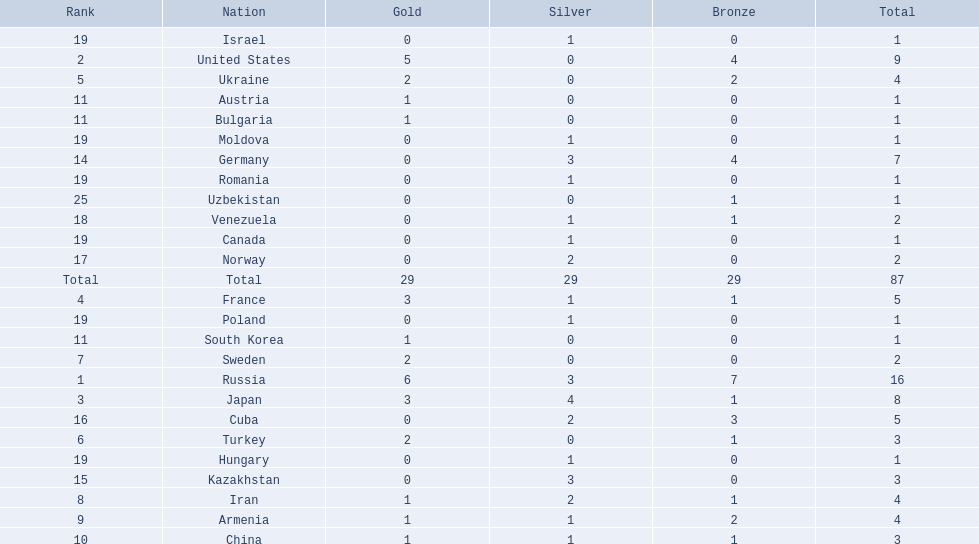Where did iran rank? 8. Where did germany rank? 14. Which of those did make it into the top 10 rank? Germany. 